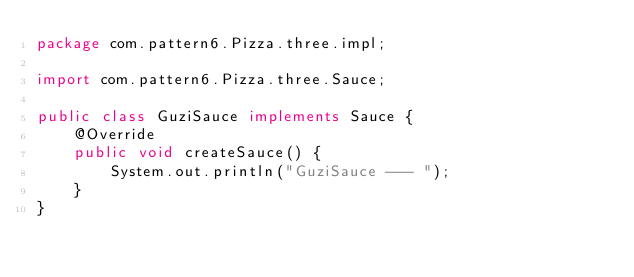Convert code to text. <code><loc_0><loc_0><loc_500><loc_500><_Java_>package com.pattern6.Pizza.three.impl;

import com.pattern6.Pizza.three.Sauce;

public class GuziSauce implements Sauce {
    @Override
    public void createSauce() {
        System.out.println("GuziSauce --- ");
    }
}
</code> 